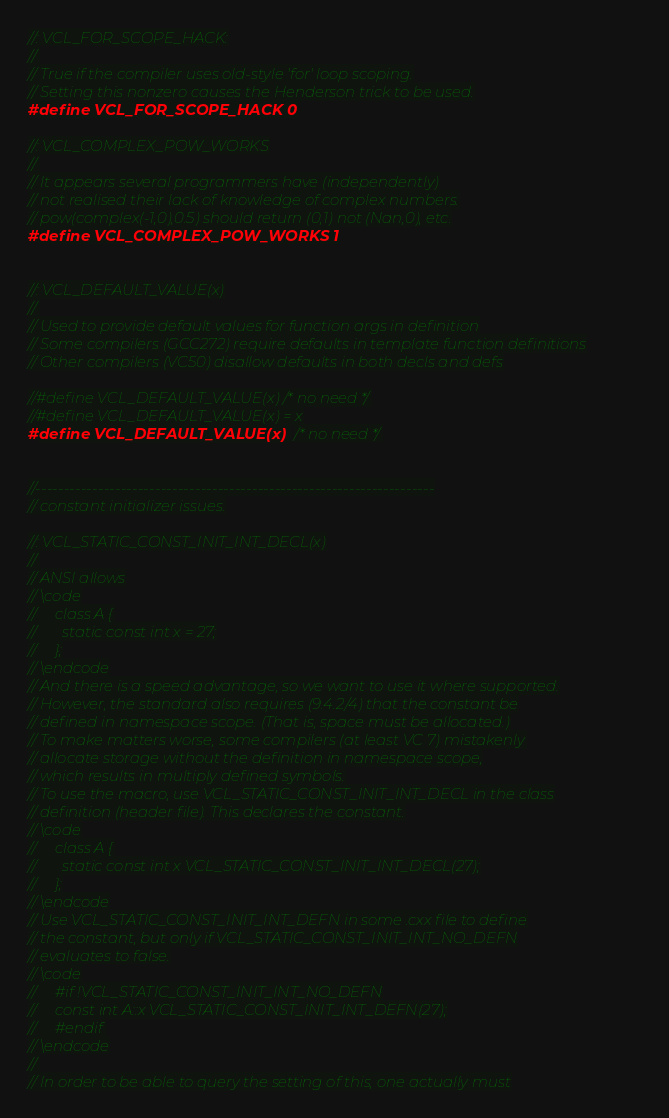Convert code to text. <code><loc_0><loc_0><loc_500><loc_500><_C_>//: VCL_FOR_SCOPE_HACK:
//
// True if the compiler uses old-style 'for' loop scoping.
// Setting this nonzero causes the Henderson trick to be used.
#define VCL_FOR_SCOPE_HACK 0

//: VCL_COMPLEX_POW_WORKS
//
// It appears several programmers have (independently)
// not realised their lack of knowledge of complex numbers.
// pow(complex(-1,0),0.5) should return (0,1) not (Nan,0), etc.
#define VCL_COMPLEX_POW_WORKS 1


//: VCL_DEFAULT_VALUE(x)
//
// Used to provide default values for function args in definition
// Some compilers (GCC272) require defaults in template function definitions
// Other compilers (VC50) disallow defaults in both decls and defs

//#define VCL_DEFAULT_VALUE(x) /* no need */
//#define VCL_DEFAULT_VALUE(x) = x
#define VCL_DEFAULT_VALUE(x) /* no need */


//----------------------------------------------------------------------
// constant initializer issues.

//: VCL_STATIC_CONST_INIT_INT_DECL(x)
//
// ANSI allows
// \code
//     class A {
//       static const int x = 27;
//     };
// \endcode
// And there is a speed advantage, so we want to use it where supported.
// However, the standard also requires (9.4.2/4) that the constant be
// defined in namespace scope. (That is, space must be allocated.)
// To make matters worse, some compilers (at least VC 7) mistakenly
// allocate storage without the definition in namespace scope,
// which results in multiply defined symbols.
// To use the macro, use VCL_STATIC_CONST_INIT_INT_DECL in the class
// definition (header file). This declares the constant.
// \code
//     class A {
//       static const int x VCL_STATIC_CONST_INIT_INT_DECL(27);
//     };
// \endcode
// Use VCL_STATIC_CONST_INIT_INT_DEFN in some .cxx file to define
// the constant, but only if VCL_STATIC_CONST_INIT_INT_NO_DEFN
// evaluates to false.
// \code
//     #if !VCL_STATIC_CONST_INIT_INT_NO_DEFN
//     const int A::x VCL_STATIC_CONST_INIT_INT_DEFN(27);
//     #endif
// \endcode
//
// In order to be able to query the setting of this, one actually must</code> 